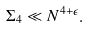<formula> <loc_0><loc_0><loc_500><loc_500>\Sigma _ { 4 } \ll N ^ { 4 + \epsilon } .</formula> 